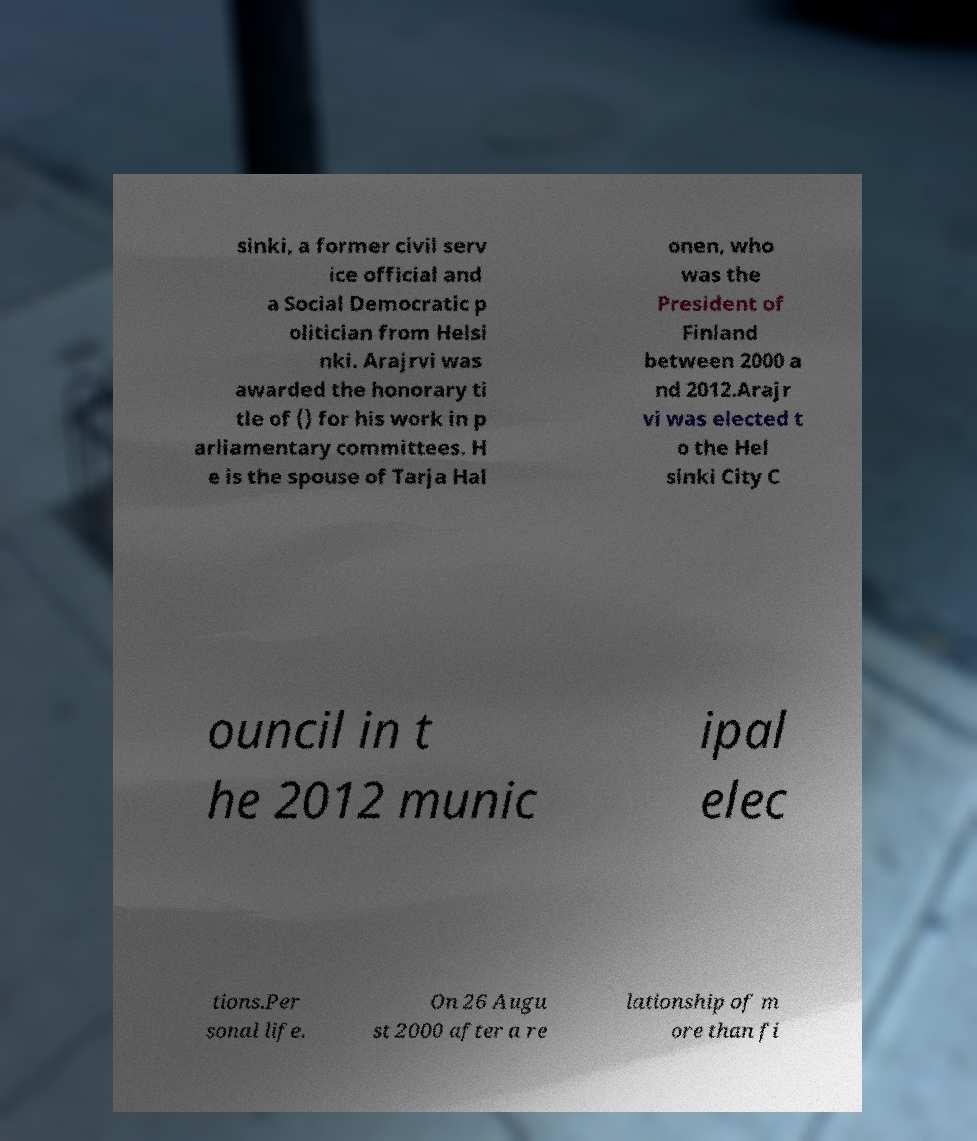Can you accurately transcribe the text from the provided image for me? sinki, a former civil serv ice official and a Social Democratic p olitician from Helsi nki. Arajrvi was awarded the honorary ti tle of () for his work in p arliamentary committees. H e is the spouse of Tarja Hal onen, who was the President of Finland between 2000 a nd 2012.Arajr vi was elected t o the Hel sinki City C ouncil in t he 2012 munic ipal elec tions.Per sonal life. On 26 Augu st 2000 after a re lationship of m ore than fi 